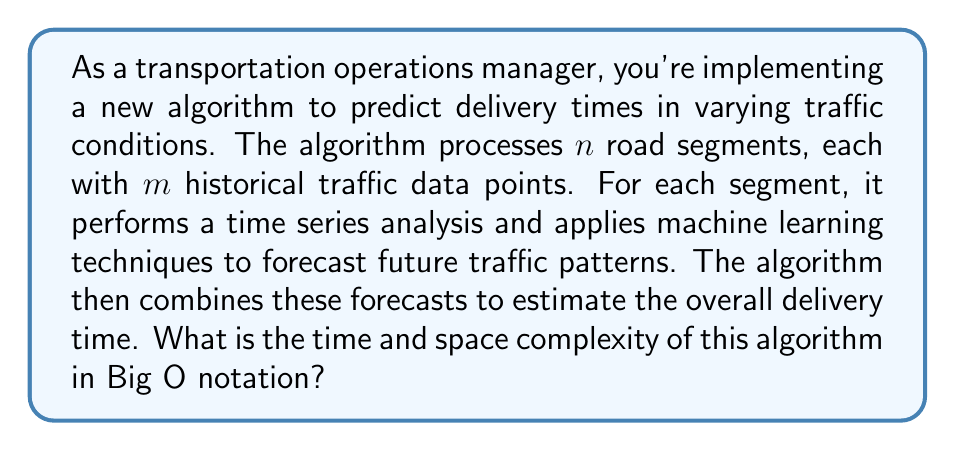Can you answer this question? Let's break down the algorithm and analyze its complexity step by step:

1. Processing road segments:
   - We have $n$ road segments to process.
   - For each segment, we analyze $m$ historical data points.
   - Time complexity for this step: $O(n \cdot m)$

2. Time series analysis:
   - Assume we're using an efficient time series analysis method like Fast Fourier Transform (FFT).
   - FFT has a time complexity of $O(m \log m)$ for $m$ data points.
   - We perform this for each of the $n$ segments.
   - Time complexity for this step: $O(n \cdot m \log m)$

3. Machine learning forecast:
   - Let's assume we're using a simple linear regression model for prediction.
   - Training a linear regression model has a time complexity of $O(m^2)$ for $m$ data points.
   - We do this for each of the $n$ segments.
   - Time complexity for this step: $O(n \cdot m^2)$

4. Combining forecasts:
   - We need to combine the forecasts from all $n$ segments.
   - This is typically a linear operation.
   - Time complexity for this step: $O(n)$

Now, let's determine the overall time complexity:
- The total time complexity is the sum of all steps: $O(n \cdot m + n \cdot m \log m + n \cdot m^2 + n)$
- Simplifying, we can see that $n \cdot m^2$ dominates the other terms.
- Therefore, the overall time complexity is $O(n \cdot m^2)$

For space complexity:
- We need to store the historical data for all segments: $O(n \cdot m)$
- The time series analysis and machine learning models may require additional space, but it's typically less than $O(n \cdot m)$
- The combined forecast requires $O(n)$ space

Therefore, the overall space complexity is $O(n \cdot m)$
Answer: Time complexity: $O(n \cdot m^2)$
Space complexity: $O(n \cdot m)$
Where $n$ is the number of road segments and $m$ is the number of historical data points per segment. 